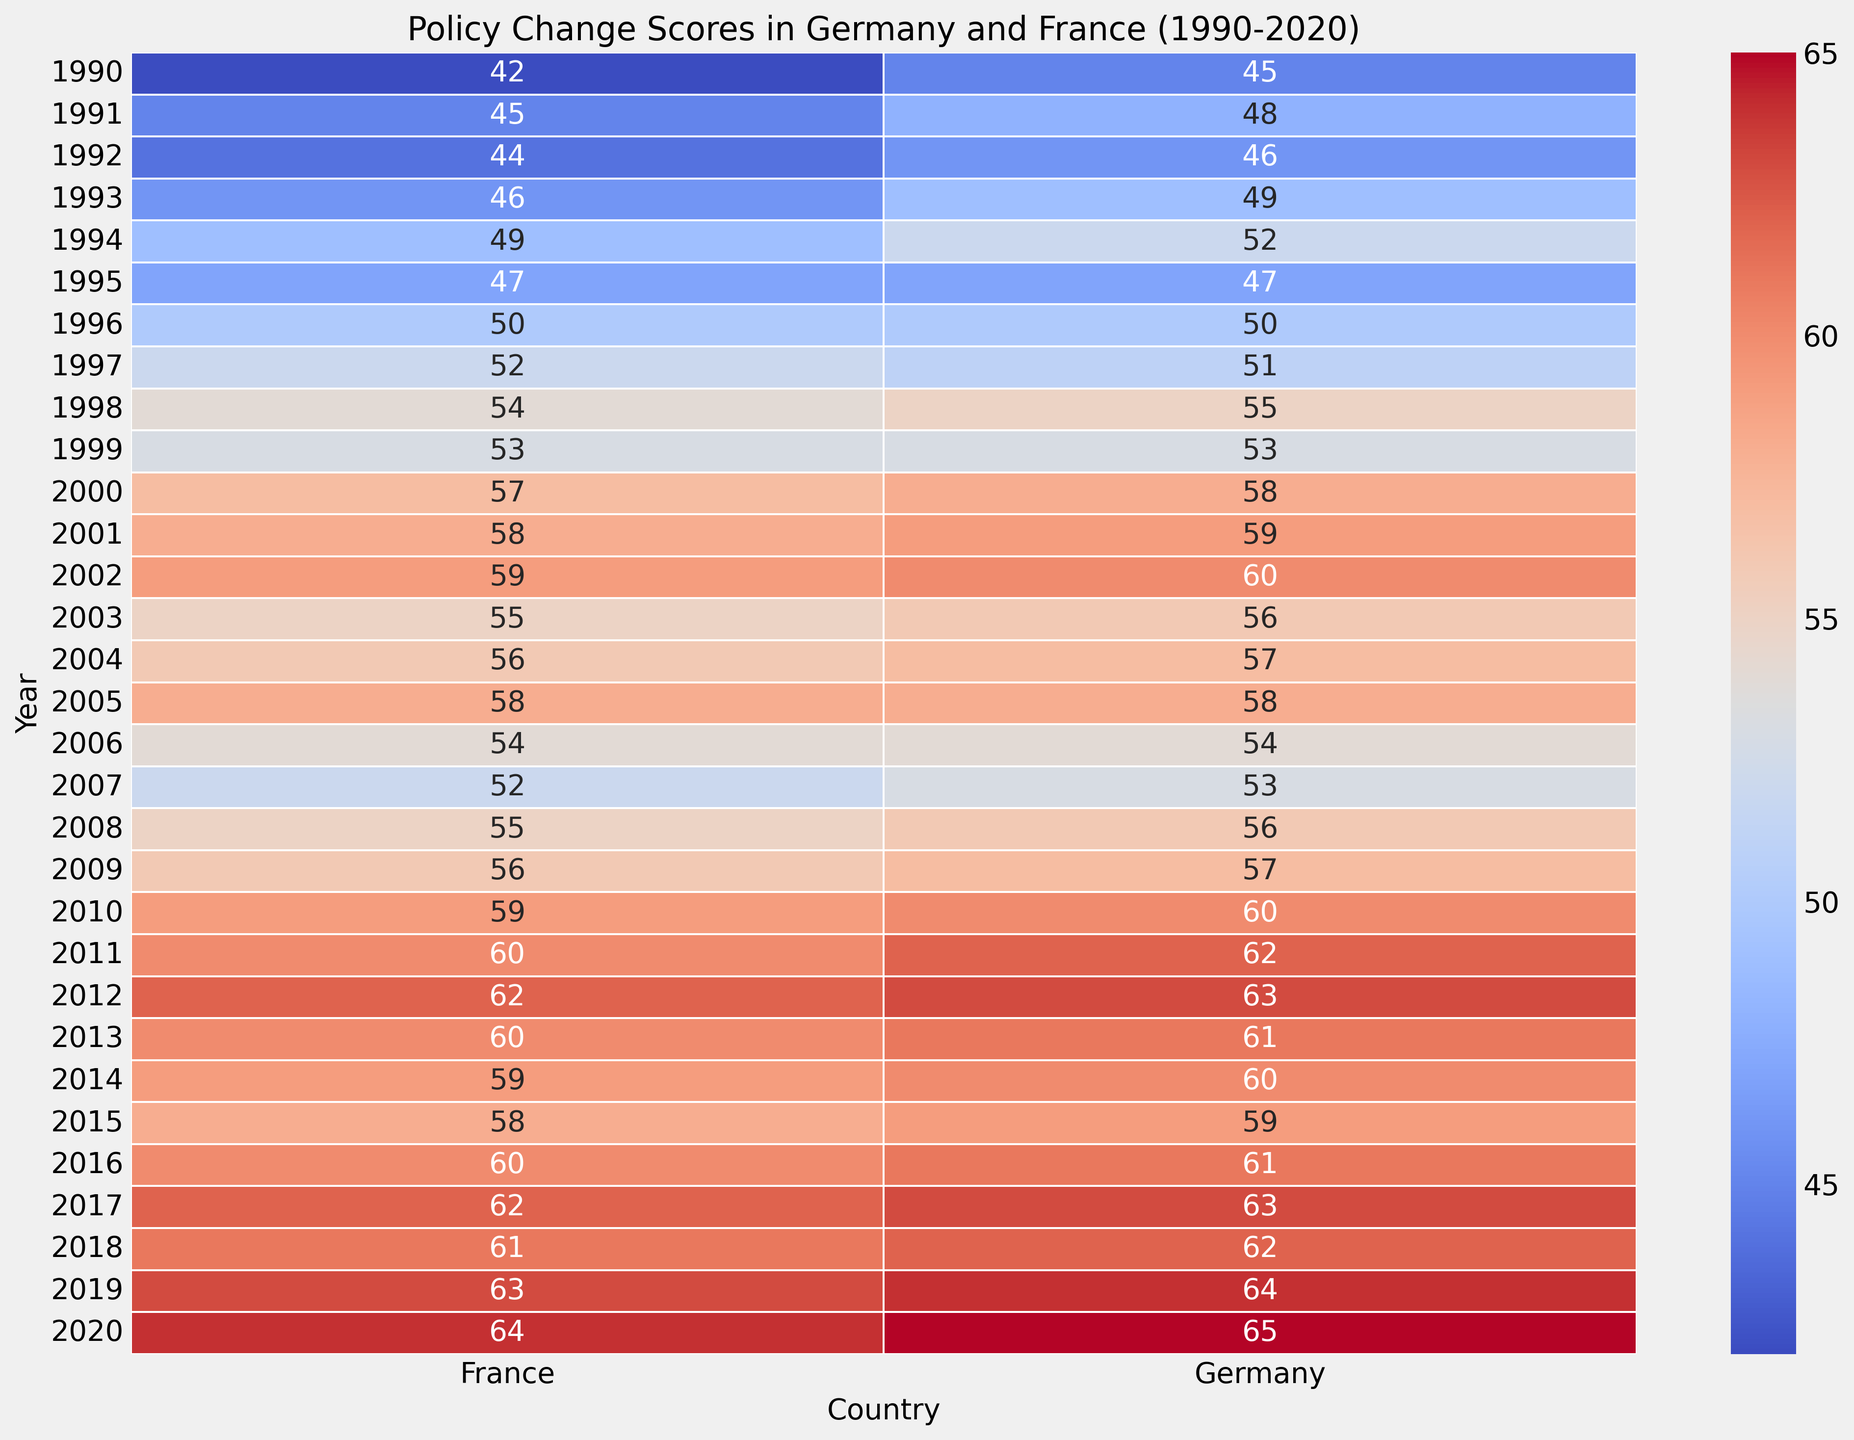What is the range of policy change scores in Germany from 1990 to 2020? The minimum policy change score in Germany from 1990 to 2020 is 45 (in 1990) and the maximum is 65 (in 2020). The range is obtained by subtracting the minimum value from the maximum value: 65 - 45 = 20.
Answer: 20 Which country shows higher policy change scores towards the end of the observed period (around 2020)? By comparing the policy change scores in 2020, Germany has a value of 65 and France has a value of 64. Therefore, Germany shows higher policy change scores in 2020.
Answer: Germany What is the average policy change score in Germany for the decades of the 1990s and 2000s? For the 1990s, the scores are: 45, 48, 46, 49, 52, 47, 50, 51, 55, 53. The average is calculated as (45+48+46+49+52+47+50+51+55+53)/10 = 49.6. For the 2000s, the scores are: 58, 59, 60, 56, 57, 58, 54, 53, 56, 57. The average is calculated as (58+59+60+56+57+58+54+53+56+57)/10 = 56.8.
Answer: 49.6 (1990s), 56.8 (2000s) How does the trend in policy change scores in Germany from 1990 to 2020 compare to France over the same period? Both Germany and France show an overall increasing trend in policy change scores from 1990 to 2020. However, Germany starts with a higher score in 1990 and continues to maintain generally higher policy change scores compared to France throughout the period.
Answer: Germany maintains higher scores In which years from 1990 to 2020 did Germany and France have equal policy change scores? According to the heatmap, the policy change scores for Germany and France did not equal each other in any given year from 1990 to 2020.
Answer: None What is the overall trend in policy changes for Germany from 1990 to 2020? The overall trend in policy change scores for Germany from 1990 to 2020 is an increasing trend. The scores start at 45 in 1990 and rise steadily over the decades, reaching 65 in 2020.
Answer: Increasing Compare the difference in policy change scores between Germany and France in the year 2000. In the year 2000, the policy change score for Germany is 58 and for France is 57. The difference is 58 - 57 = 1.
Answer: 1 